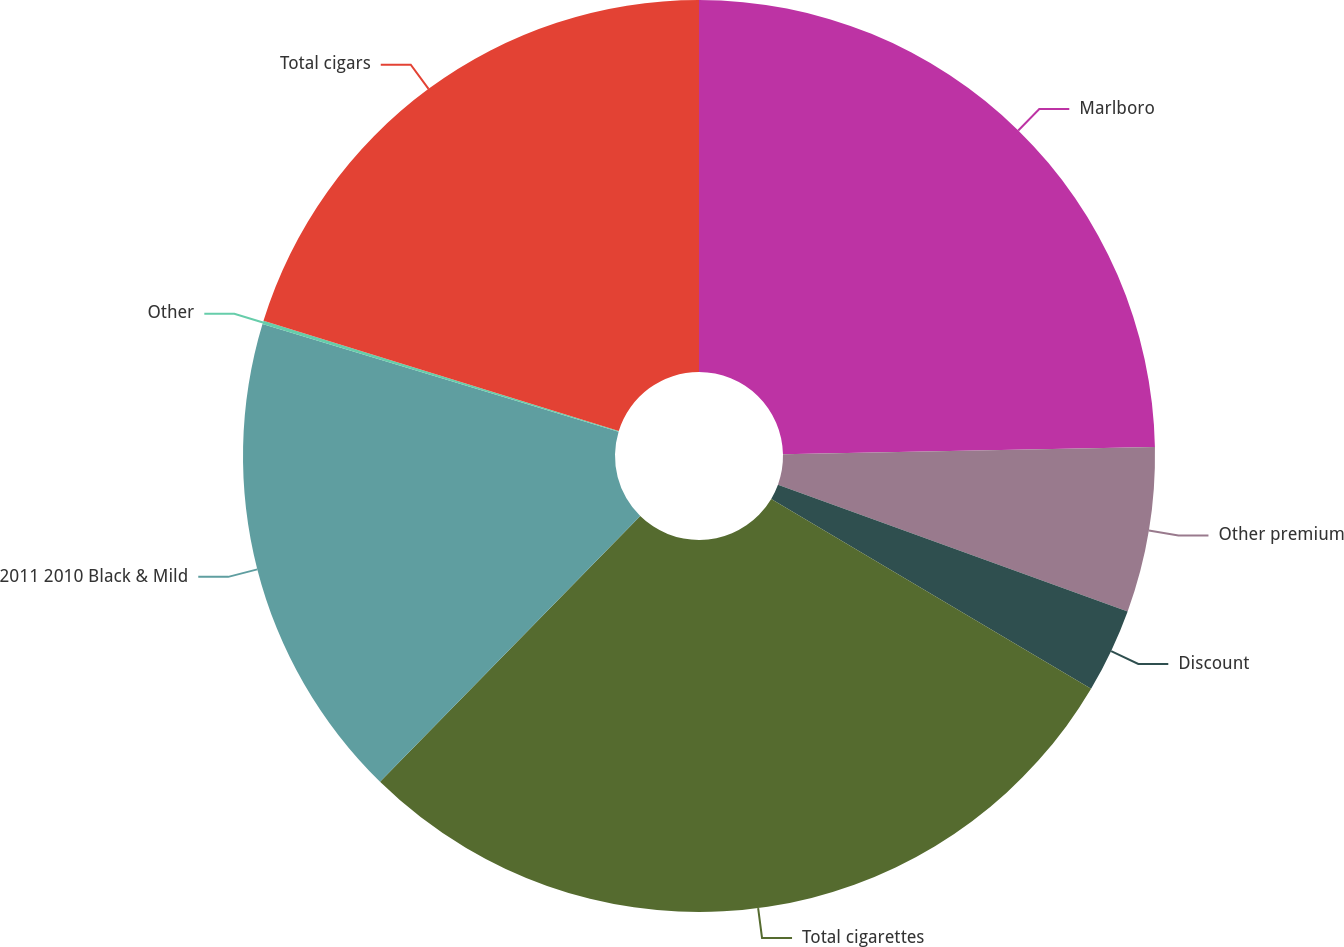Convert chart. <chart><loc_0><loc_0><loc_500><loc_500><pie_chart><fcel>Marlboro<fcel>Other premium<fcel>Discount<fcel>Total cigarettes<fcel>2011 2010 Black & Mild<fcel>Other<fcel>Total cigars<nl><fcel>24.69%<fcel>5.85%<fcel>2.99%<fcel>28.8%<fcel>17.34%<fcel>0.12%<fcel>20.21%<nl></chart> 